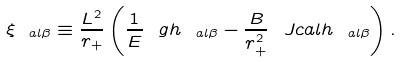<formula> <loc_0><loc_0><loc_500><loc_500>\xi _ { \ a l \beta } \equiv \frac { L ^ { 2 } } { r _ { + } } \left ( \frac { 1 } { E } \ g h _ { \ a l \beta } - \frac { B } { r _ { + } ^ { 2 } } \ J c a l h _ { \ a l \beta } \right ) .</formula> 